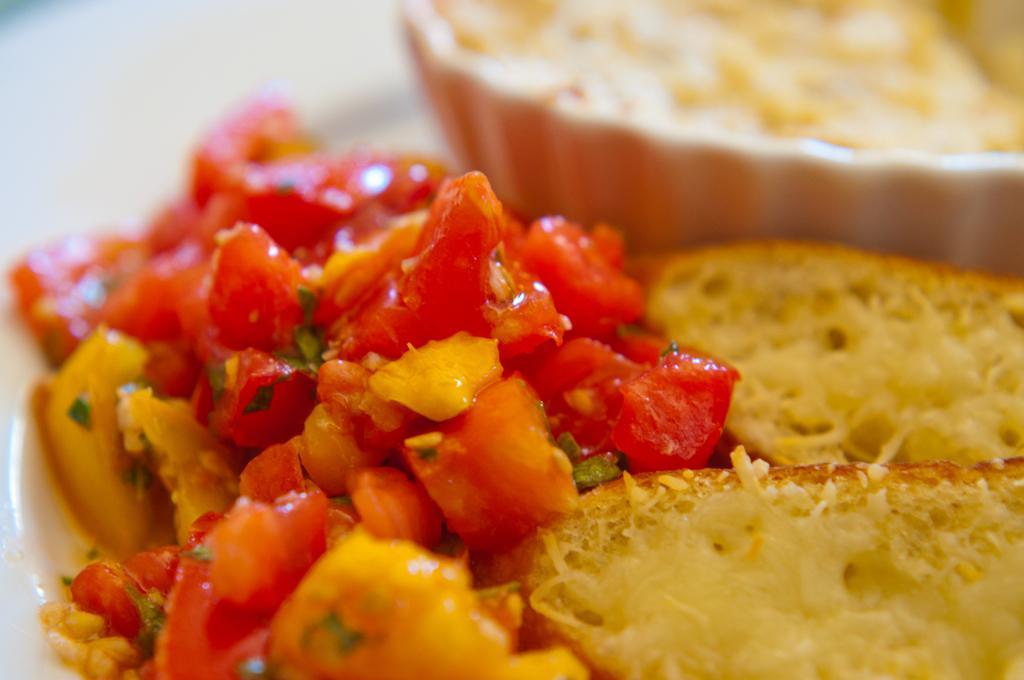Can you describe this image briefly? In this image, I can see the food items, which are made with tomatoes, capsicum, bread and few other ingredients. In the background, that looks like a bowl. 